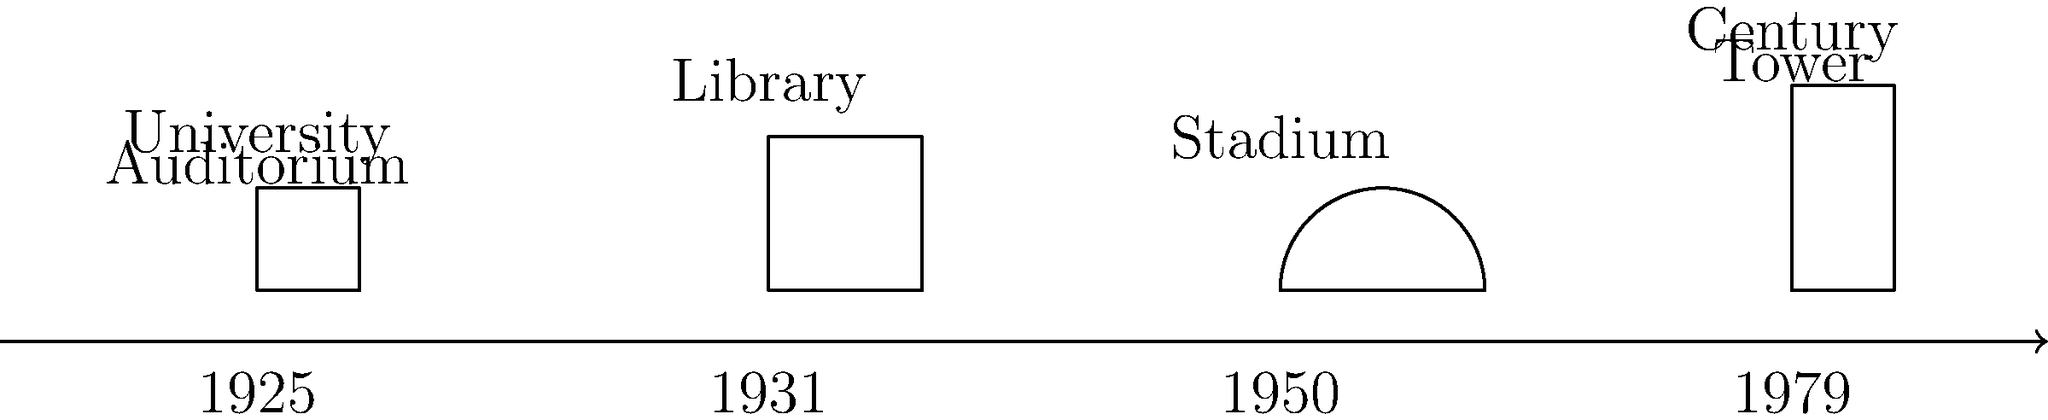Based on the timeline of architectural evolution at the University of Florida, which iconic building was constructed in 1979, marking a significant addition to the campus skyline? Let's analyze the timeline of architectural evolution at the University of Florida:

1. 1925: The first building shown is the University Auditorium, a classic structure with a rectangular shape.

2. 1931: The next building is the Library, which appears larger and taller than the Auditorium.

3. 1950: The timeline shows the construction of the Stadium, recognizable by its curved roof structure.

4. 1979: The final building on the timeline is a tall, narrow structure labeled as the Century Tower.

The question asks about an iconic building constructed in 1979. Looking at the timeline, we can see that the Century Tower was built in that year. This structure stands out due to its height and narrow profile, which would indeed make it a significant addition to the campus skyline.

As a local Gainesville resident since the 1970s, you would have witnessed the construction of the Century Tower and its impact on the University of Florida campus.
Answer: Century Tower 